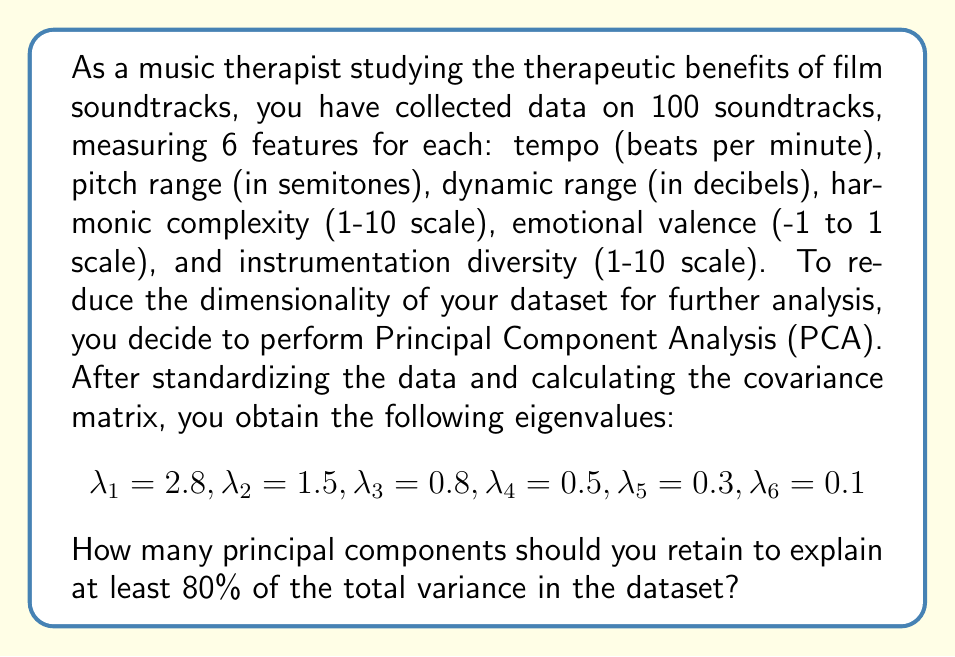Can you solve this math problem? To solve this problem, we need to follow these steps:

1. Calculate the total variance:
   The total variance is the sum of all eigenvalues.
   $$\text{Total Variance} = \sum_{i=1}^6 \lambda_i = 2.8 + 1.5 + 0.8 + 0.5 + 0.3 + 0.1 = 6$$

2. Calculate the proportion of variance explained by each principal component:
   For each eigenvalue, divide it by the total variance.
   $$\text{Proportion}_1 = \frac{2.8}{6} = 0.4667 \text{ or } 46.67\%$$
   $$\text{Proportion}_2 = \frac{1.5}{6} = 0.2500 \text{ or } 25.00\%$$
   $$\text{Proportion}_3 = \frac{0.8}{6} = 0.1333 \text{ or } 13.33\%$$
   $$\text{Proportion}_4 = \frac{0.5}{6} = 0.0833 \text{ or } 8.33\%$$
   $$\text{Proportion}_5 = \frac{0.3}{6} = 0.0500 \text{ or } 5.00\%$$
   $$\text{Proportion}_6 = \frac{0.1}{6} = 0.0167 \text{ or } 1.67\%$$

3. Calculate the cumulative proportion of variance explained:
   Sum the proportions starting from the first principal component until we reach or exceed 80%.
   $$\text{Cumulative}_1 = 46.67\%$$
   $$\text{Cumulative}_2 = 46.67\% + 25.00\% = 71.67\%$$
   $$\text{Cumulative}_3 = 71.67\% + 13.33\% = 85.00\%$$

4. Determine the number of principal components:
   We need to retain the first 3 principal components to explain at least 80% of the total variance.
Answer: 3 principal components 